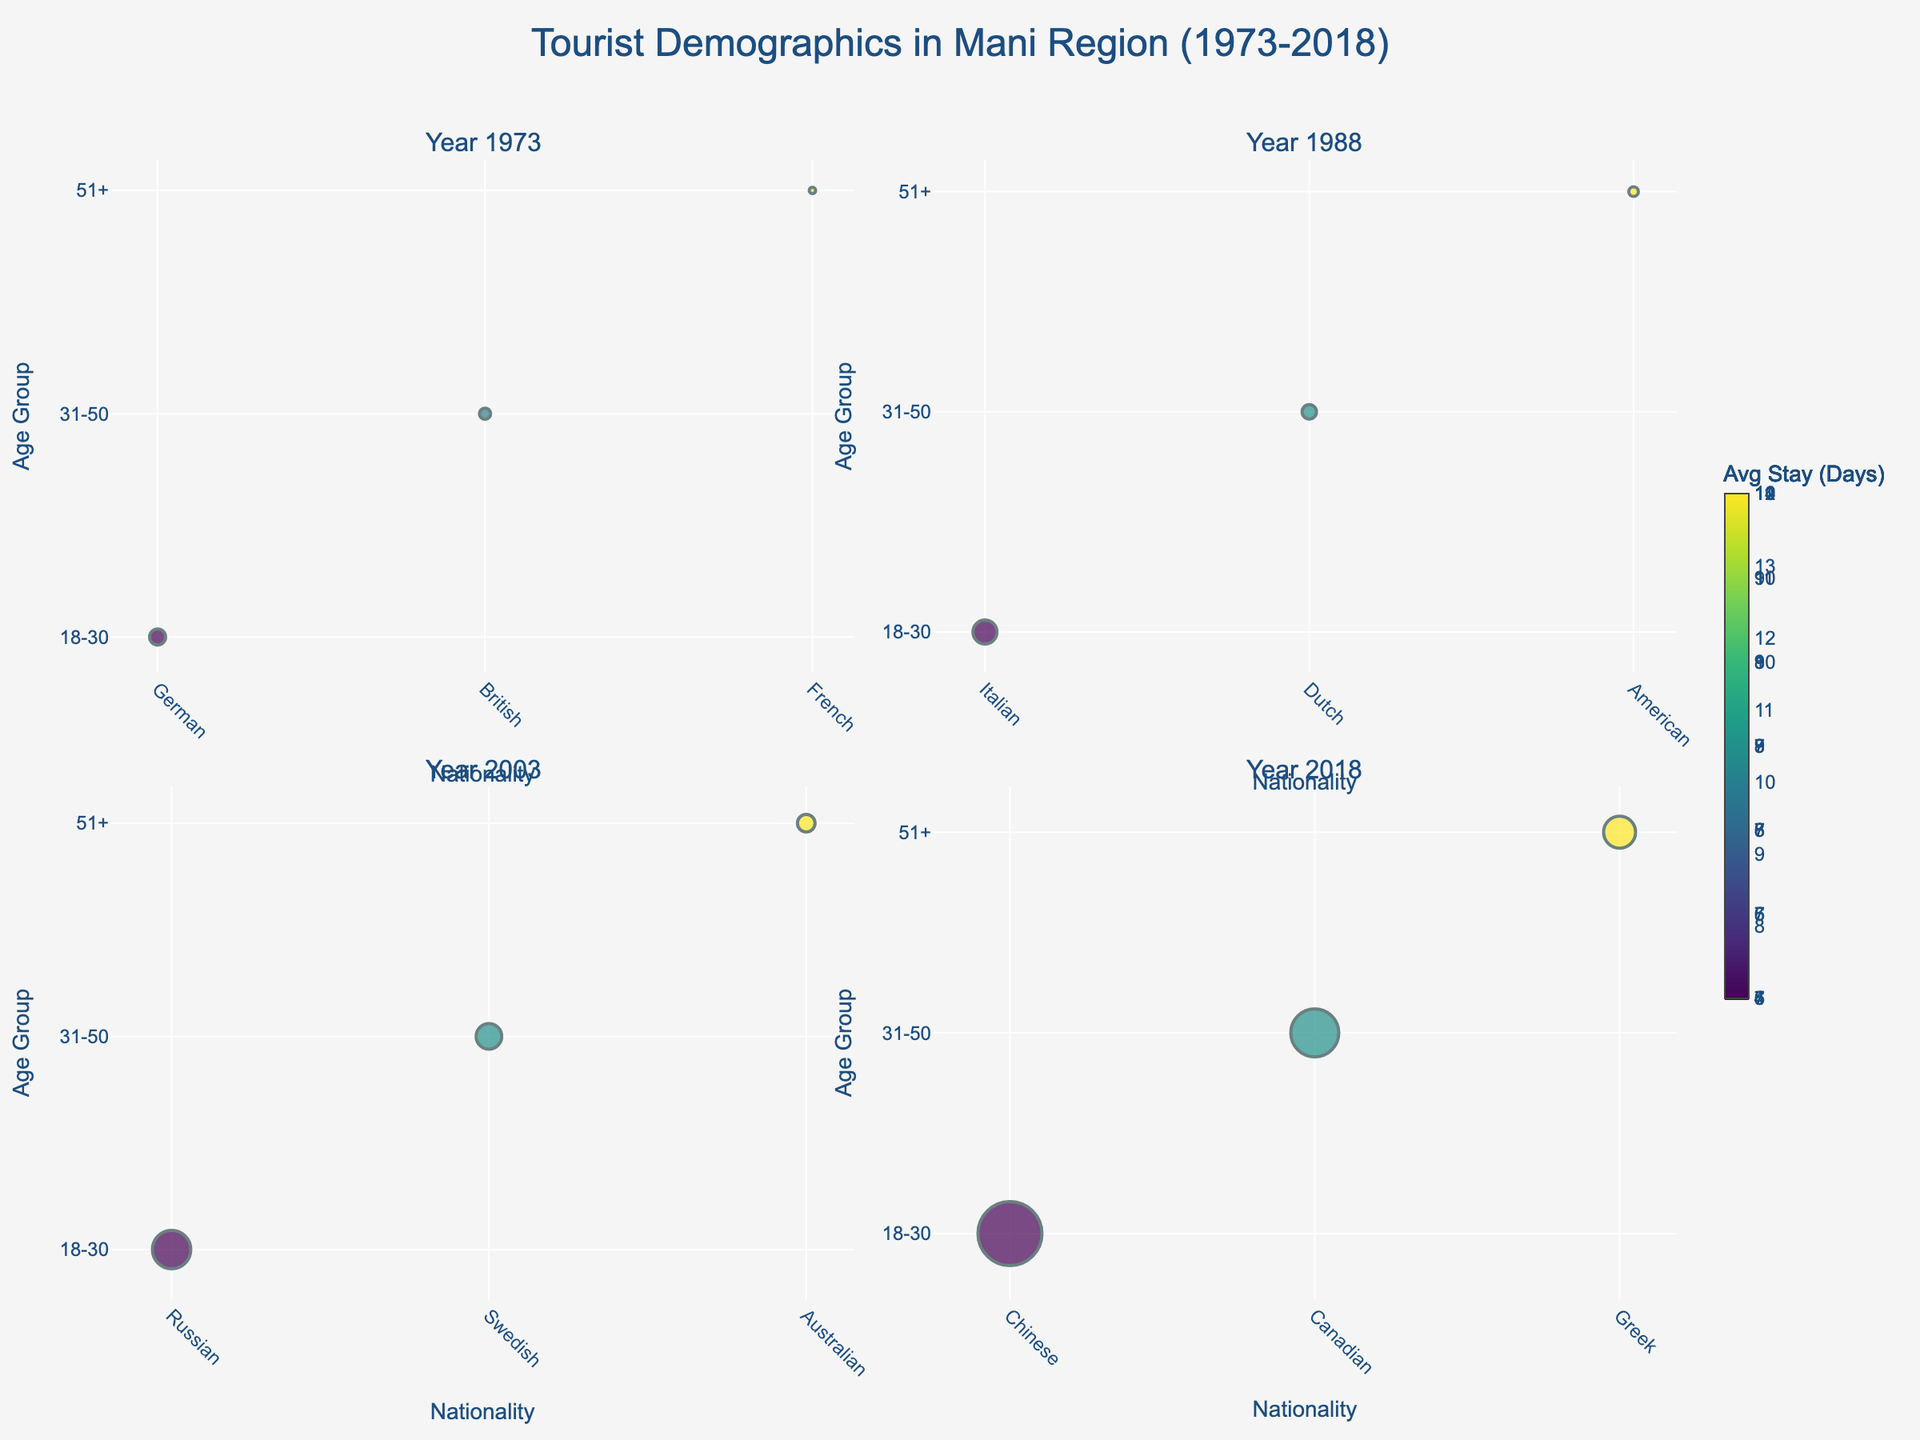What is the nationality of tourists in the 18-30 age group in the year 2018? The nationality labels are shown on the x-axis for each subplot. For the year 2018, the bubble at the intersection of the 18-30 age group and the x-axis shows 'Chinese'.
Answer: Chinese Which year had the highest number of tourists in the 51+ age group? Sizes of the bubbles represent the number of visitors. The largest bubble in the 51+ age group is in 2018.
Answer: 2018 How does the average stay duration of French tourists in 1973 compare to Australian tourists in 2003? The average stay duration is indicated by the color of the bubbles. By comparing the color bar, French tourists in 1973 have a duration of 14 days, while Australian tourists in 2003 have 11 days.
Answer: French tourists stay longer by 3 days How many visitors were there in total for all age groups in 1973? Sum the number of visitors indicated within the bubbles for each age group: 5000 (German) + 3500 (British) + 2000 (French) = 10500.
Answer: 10500 Which age group had tourists of Canadian nationality in 2018 and what was their average stay duration? The bubble corresponding to 'Canadian' is in the 31-50 age group. The color indicates the average stay duration, which according to the color scale is 7 days.
Answer: 31-50, 7 days Which year had the smallest bubble for the 31-50 age group and what does it represent? The smallest bubble for the 31-50 age group is in the year 1973, representing 3500 visitors.
Answer: 1973, 3500 visitors What is the difference in the average stay duration between Dutch tourists in 1988 and Russian tourists in 2003? The color of the bubbles represents the average stay duration. From the color scale, Dutch tourists in 1988 stayed for 9 days, while Russian tourists in 2003 stayed for 5 days. The difference is 9 - 5 = 4 days.
Answer: 4 days Which nationality had the highest number of visitors in the year 2003 and in which age group? The largest bubble in the 2003 subplot is for 'Russian' in the 18-30 age group, indicating the highest visitors.
Answer: Russian, 18-30 age group How did the number of young (18-30) tourists change from 1973 to 1988? The size of the bubbles for the 18-30 age group in 1973 is 5000 (German) and in 1988 it is 7500 (Italian), showing an increase.
Answer: Increased from 5000 to 7500 